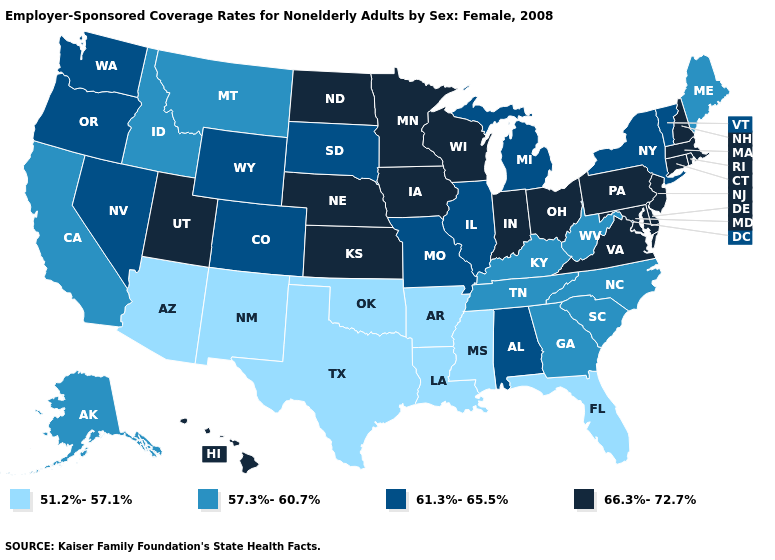Name the states that have a value in the range 51.2%-57.1%?
Quick response, please. Arizona, Arkansas, Florida, Louisiana, Mississippi, New Mexico, Oklahoma, Texas. Among the states that border Nevada , which have the lowest value?
Keep it brief. Arizona. Which states have the lowest value in the Northeast?
Be succinct. Maine. What is the value of Pennsylvania?
Short answer required. 66.3%-72.7%. Is the legend a continuous bar?
Write a very short answer. No. Name the states that have a value in the range 66.3%-72.7%?
Be succinct. Connecticut, Delaware, Hawaii, Indiana, Iowa, Kansas, Maryland, Massachusetts, Minnesota, Nebraska, New Hampshire, New Jersey, North Dakota, Ohio, Pennsylvania, Rhode Island, Utah, Virginia, Wisconsin. Does California have a higher value than Arkansas?
Concise answer only. Yes. Does Florida have the highest value in the South?
Be succinct. No. Does Minnesota have the highest value in the MidWest?
Concise answer only. Yes. What is the value of Louisiana?
Give a very brief answer. 51.2%-57.1%. Which states have the lowest value in the Northeast?
Give a very brief answer. Maine. Which states have the highest value in the USA?
Write a very short answer. Connecticut, Delaware, Hawaii, Indiana, Iowa, Kansas, Maryland, Massachusetts, Minnesota, Nebraska, New Hampshire, New Jersey, North Dakota, Ohio, Pennsylvania, Rhode Island, Utah, Virginia, Wisconsin. Does Colorado have a lower value than Vermont?
Give a very brief answer. No. Which states have the lowest value in the USA?
Be succinct. Arizona, Arkansas, Florida, Louisiana, Mississippi, New Mexico, Oklahoma, Texas. What is the value of Virginia?
Answer briefly. 66.3%-72.7%. 